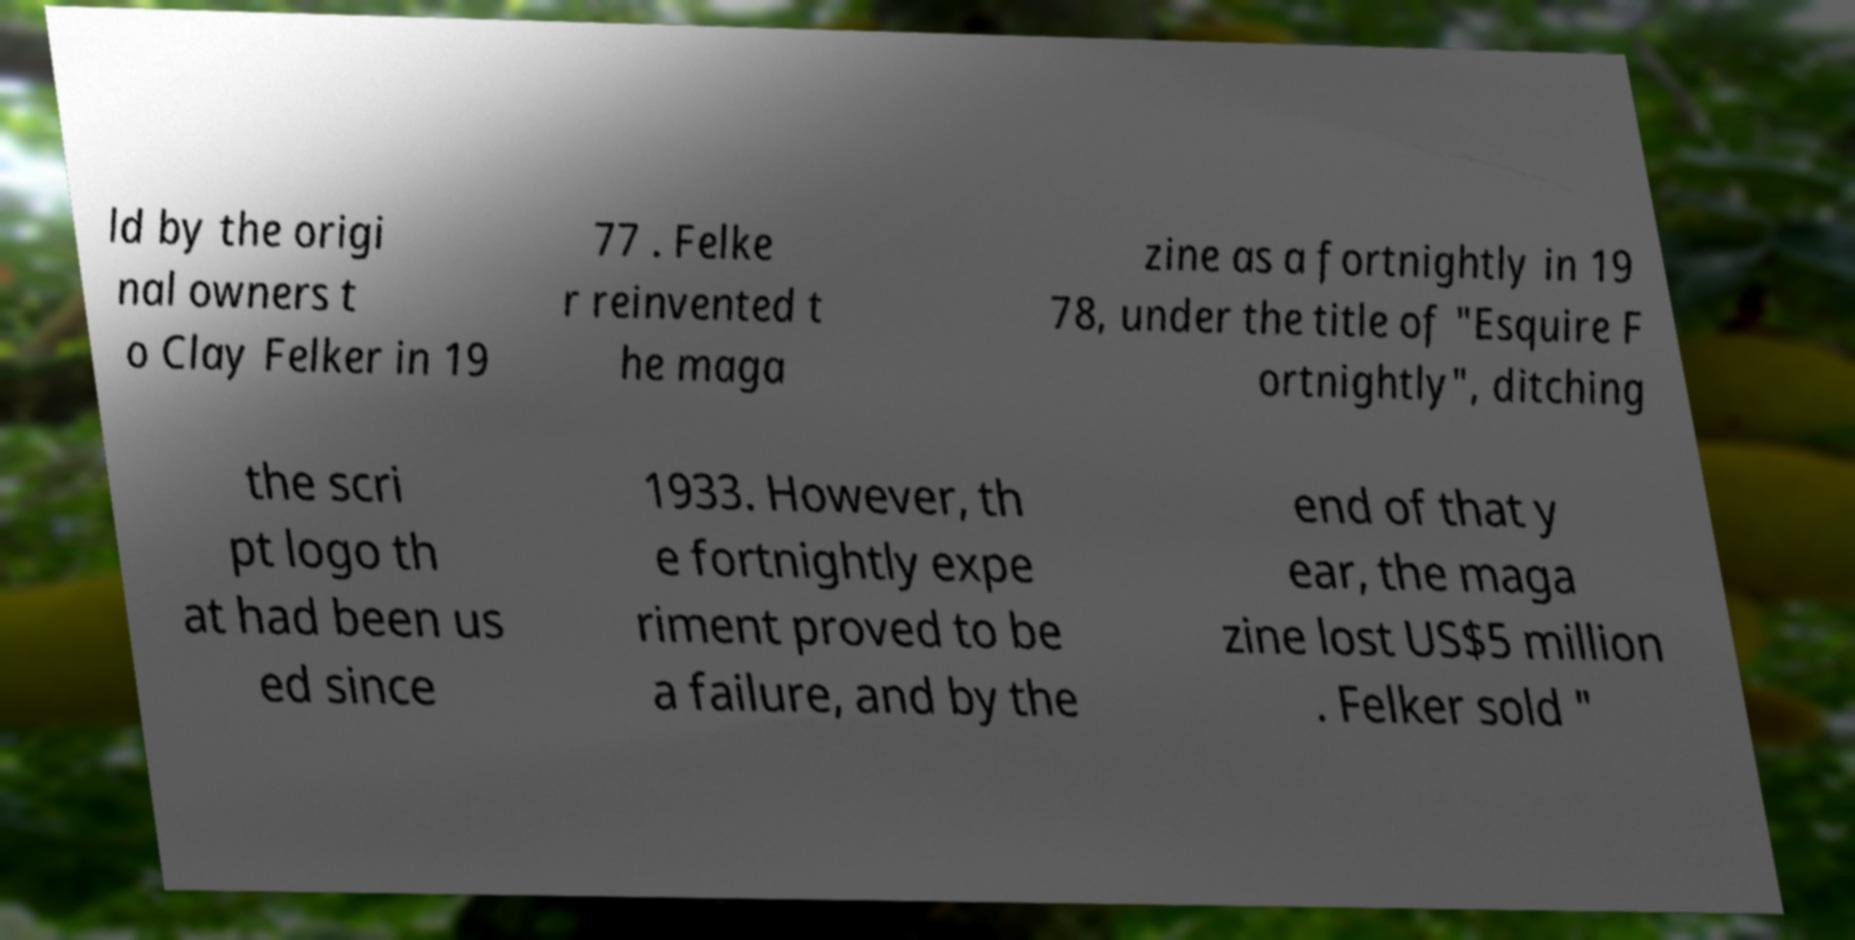I need the written content from this picture converted into text. Can you do that? ld by the origi nal owners t o Clay Felker in 19 77 . Felke r reinvented t he maga zine as a fortnightly in 19 78, under the title of "Esquire F ortnightly", ditching the scri pt logo th at had been us ed since 1933. However, th e fortnightly expe riment proved to be a failure, and by the end of that y ear, the maga zine lost US$5 million . Felker sold " 